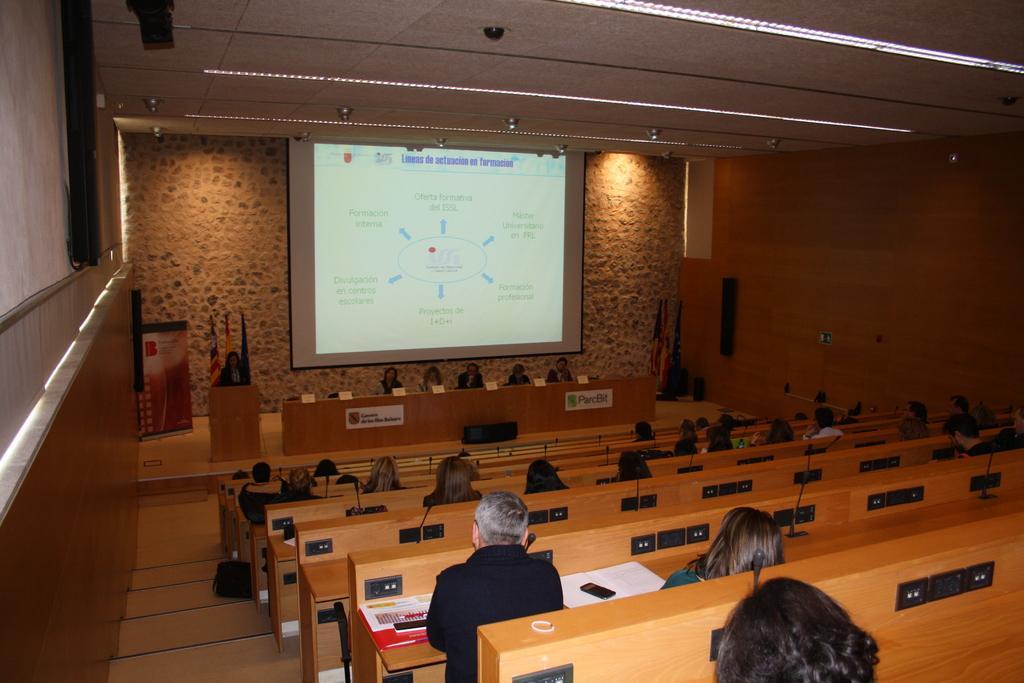How would you summarize this image in a sentence or two? In this image we can see few people sitting in a room looks like an auditorium, there are papers, mic´s, name boards on the table, a person standing near the podium and flags behind the person and there is a presentation screen and lights attached to the ceiling. 